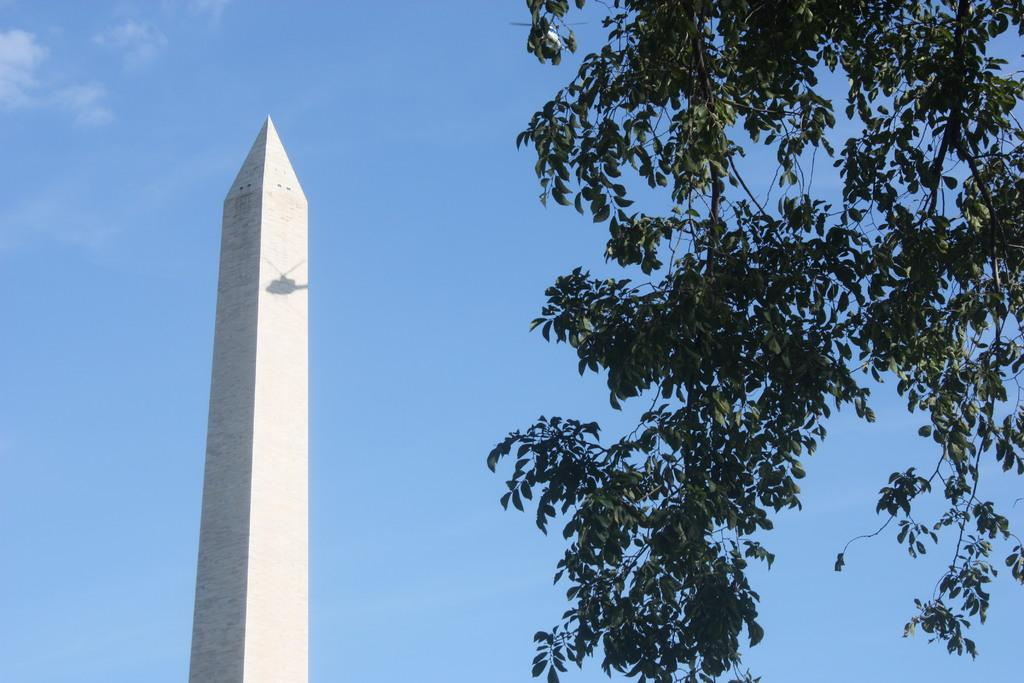What is the main structure in the image? There is a huge tower in the image. What is the color of the tower? The tower is white in color. What type of vegetation can be seen in the image? There are trees in the image. What is the color of the trees? The trees are green in color. What can be seen in the background of the image? The sky is visible in the background of the image. Where can the basin of honey be found in the image? There is no basin of honey present in the image. What type of bells are hanging from the trees in the image? There are no bells hanging from the trees in the image. 